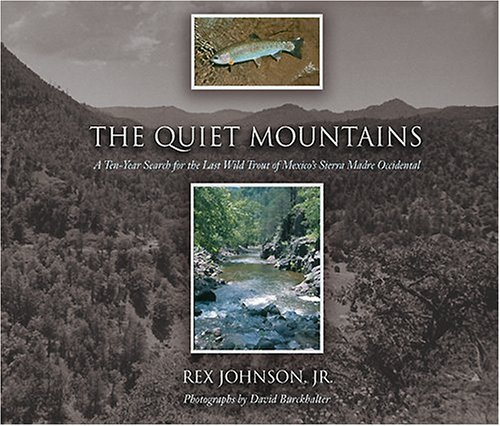Can you tell me more about the focus of the book? The book focuses on the author's ten-year journey searching for the last wild trout in the Sierra Madre Occidental of Mexico, highlighting themes of persistence, nature, and conservation. 